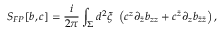<formula> <loc_0><loc_0><loc_500><loc_500>S _ { F P } [ b , c ] = \frac { i } { 2 \pi } \int _ { \Sigma } d ^ { 2 } \xi \, \left ( c ^ { z } \partial _ { \bar { z } } b _ { z z } + c ^ { \bar { z } } \partial _ { z } b _ { \bar { z } \bar { z } } \right ) ,</formula> 